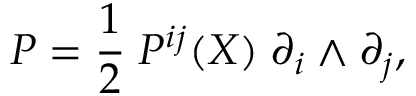<formula> <loc_0><loc_0><loc_500><loc_500>P = \frac { 1 } { 2 } \, P ^ { i j } ( X ) \, \partial _ { i } \wedge \partial _ { j } ,</formula> 